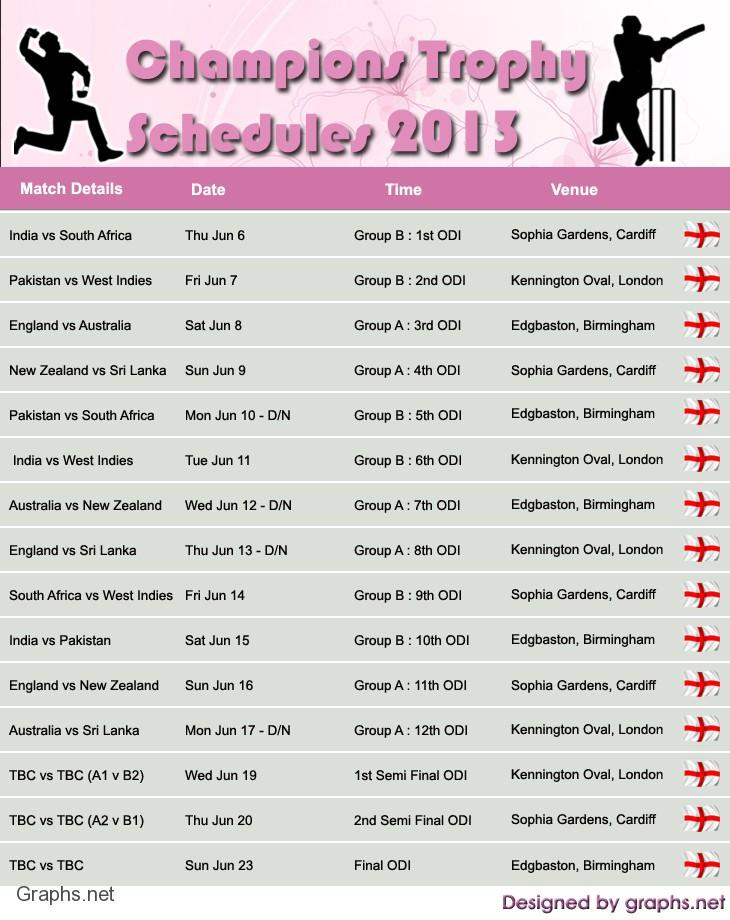Mention a couple of crucial points in this snapshot. There are two matches scheduled for Friday, Kennington Oval, a venue in London, has hosted a total of 5 matches. There are two matches scheduled for Saturday. 